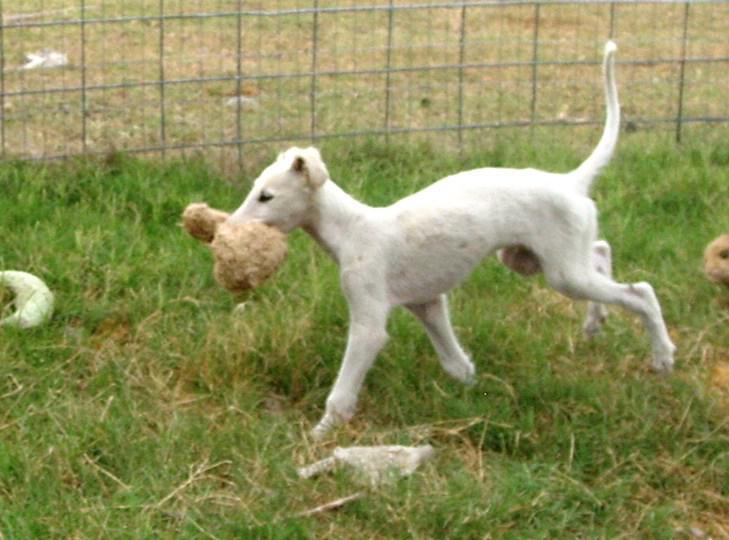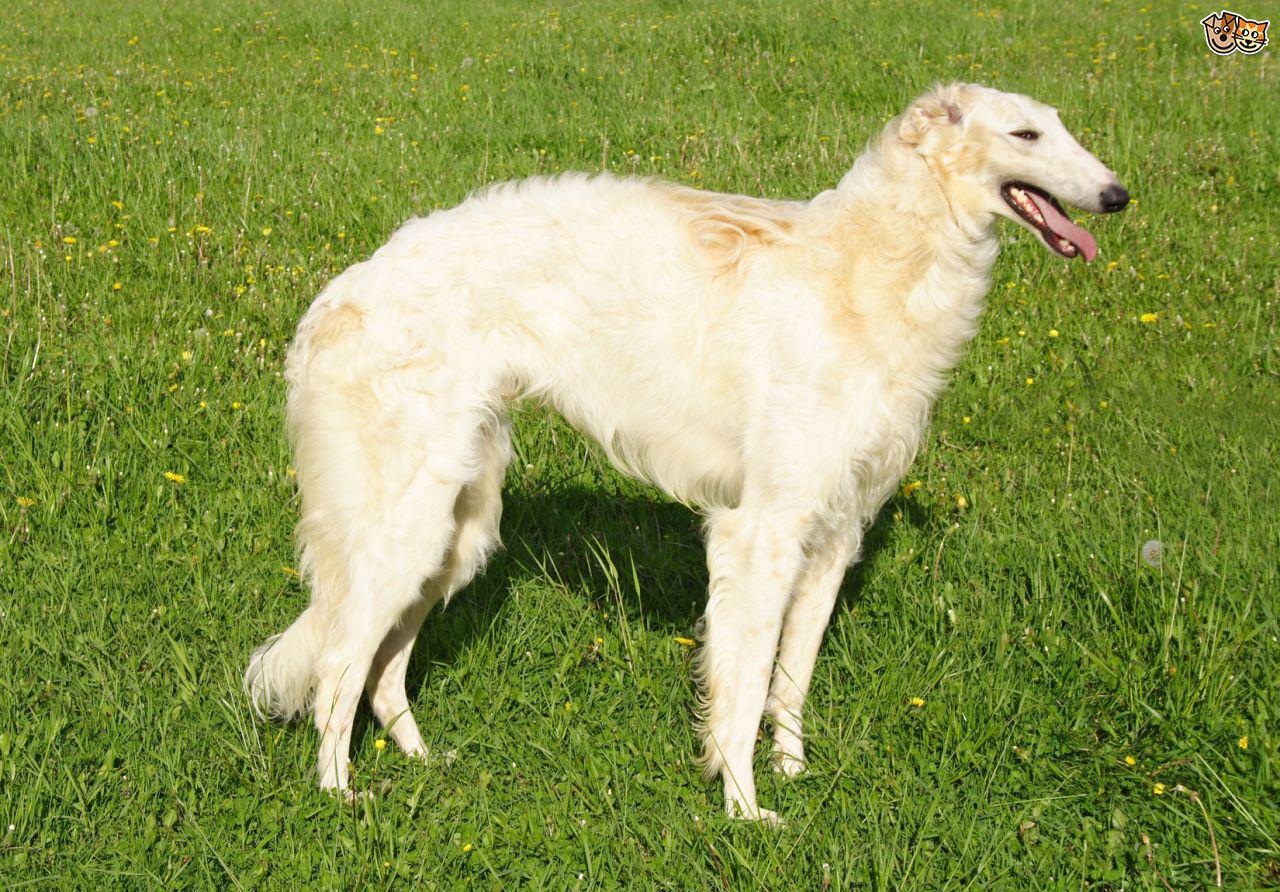The first image is the image on the left, the second image is the image on the right. For the images displayed, is the sentence "One of the images contains exactly three dogs." factually correct? Answer yes or no. No. 